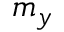Convert formula to latex. <formula><loc_0><loc_0><loc_500><loc_500>m _ { y }</formula> 